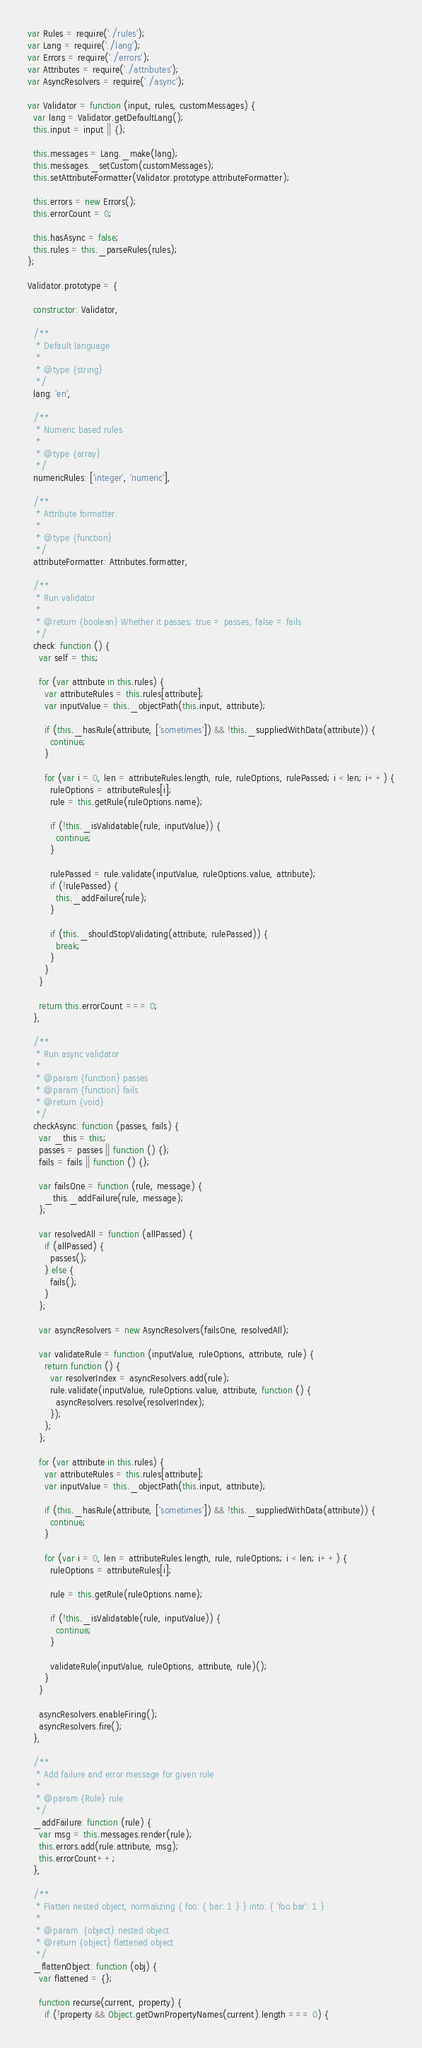<code> <loc_0><loc_0><loc_500><loc_500><_JavaScript_>var Rules = require('./rules');
var Lang = require('./lang');
var Errors = require('./errors');
var Attributes = require('./attributes');
var AsyncResolvers = require('./async');

var Validator = function (input, rules, customMessages) {
  var lang = Validator.getDefaultLang();
  this.input = input || {};

  this.messages = Lang._make(lang);
  this.messages._setCustom(customMessages);
  this.setAttributeFormatter(Validator.prototype.attributeFormatter);

  this.errors = new Errors();
  this.errorCount = 0;

  this.hasAsync = false;
  this.rules = this._parseRules(rules);
};

Validator.prototype = {

  constructor: Validator,

  /**
   * Default language
   *
   * @type {string}
   */
  lang: 'en',

  /**
   * Numeric based rules
   *
   * @type {array}
   */
  numericRules: ['integer', 'numeric'],

  /**
   * Attribute formatter.
   *
   * @type {function}
   */
  attributeFormatter: Attributes.formatter,

  /**
   * Run validator
   *
   * @return {boolean} Whether it passes; true = passes, false = fails
   */
  check: function () {
    var self = this;

    for (var attribute in this.rules) {
      var attributeRules = this.rules[attribute];
      var inputValue = this._objectPath(this.input, attribute);

      if (this._hasRule(attribute, ['sometimes']) && !this._suppliedWithData(attribute)) {
        continue;
      }

      for (var i = 0, len = attributeRules.length, rule, ruleOptions, rulePassed; i < len; i++) {
        ruleOptions = attributeRules[i];
        rule = this.getRule(ruleOptions.name);

        if (!this._isValidatable(rule, inputValue)) {
          continue;
        }

        rulePassed = rule.validate(inputValue, ruleOptions.value, attribute);
        if (!rulePassed) {
          this._addFailure(rule);
        }

        if (this._shouldStopValidating(attribute, rulePassed)) {
          break;
        }
      }
    }

    return this.errorCount === 0;
  },

  /**
   * Run async validator
   *
   * @param {function} passes
   * @param {function} fails
   * @return {void}
   */
  checkAsync: function (passes, fails) {
    var _this = this;
    passes = passes || function () {};
    fails = fails || function () {};

    var failsOne = function (rule, message) {
      _this._addFailure(rule, message);
    };

    var resolvedAll = function (allPassed) {
      if (allPassed) {
        passes();
      } else {
        fails();
      }
    };

    var asyncResolvers = new AsyncResolvers(failsOne, resolvedAll);

    var validateRule = function (inputValue, ruleOptions, attribute, rule) {
      return function () {
        var resolverIndex = asyncResolvers.add(rule);
        rule.validate(inputValue, ruleOptions.value, attribute, function () {
          asyncResolvers.resolve(resolverIndex);
        });
      };
    };

    for (var attribute in this.rules) {
      var attributeRules = this.rules[attribute];
      var inputValue = this._objectPath(this.input, attribute);

      if (this._hasRule(attribute, ['sometimes']) && !this._suppliedWithData(attribute)) {
        continue;
      }

      for (var i = 0, len = attributeRules.length, rule, ruleOptions; i < len; i++) {
        ruleOptions = attributeRules[i];

        rule = this.getRule(ruleOptions.name);

        if (!this._isValidatable(rule, inputValue)) {
          continue;
        }

        validateRule(inputValue, ruleOptions, attribute, rule)();
      }
    }

    asyncResolvers.enableFiring();
    asyncResolvers.fire();
  },

  /**
   * Add failure and error message for given rule
   *
   * @param {Rule} rule
   */
  _addFailure: function (rule) {
    var msg = this.messages.render(rule);
    this.errors.add(rule.attribute, msg);
    this.errorCount++;
  },

  /**
   * Flatten nested object, normalizing { foo: { bar: 1 } } into: { 'foo.bar': 1 }
   *
   * @param  {object} nested object
   * @return {object} flattened object
   */
  _flattenObject: function (obj) {
    var flattened = {};

    function recurse(current, property) {
      if (!property && Object.getOwnPropertyNames(current).length === 0) {</code> 